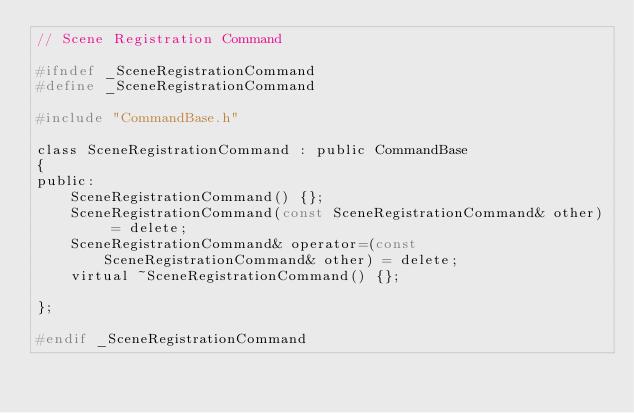<code> <loc_0><loc_0><loc_500><loc_500><_C_>// Scene Registration Command

#ifndef _SceneRegistrationCommand
#define _SceneRegistrationCommand

#include "CommandBase.h"

class SceneRegistrationCommand : public CommandBase
{
public:
	SceneRegistrationCommand() {};
	SceneRegistrationCommand(const SceneRegistrationCommand& other) = delete;
	SceneRegistrationCommand& operator=(const SceneRegistrationCommand& other) = delete;
	virtual ~SceneRegistrationCommand() {};

};

#endif _SceneRegistrationCommand</code> 